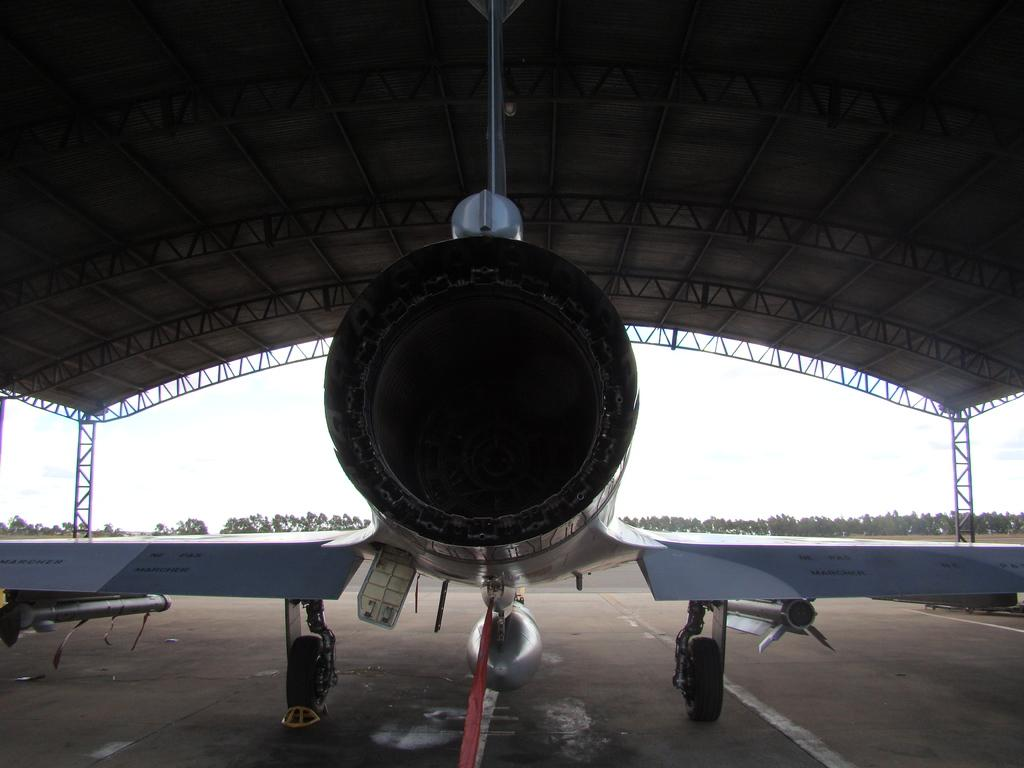What is the main subject of the image? The main subject of the image is an airplane on the ground. What else can be seen in the image besides the airplane? There is a shelter and trees in the image. What is visible in the background of the image? The sky is visible in the background of the image. Where is the tub located in the image? There is no tub present in the image. What type of base is supporting the airplane in the image? The image does not show a specific base supporting the airplane; it is simply on the ground. 